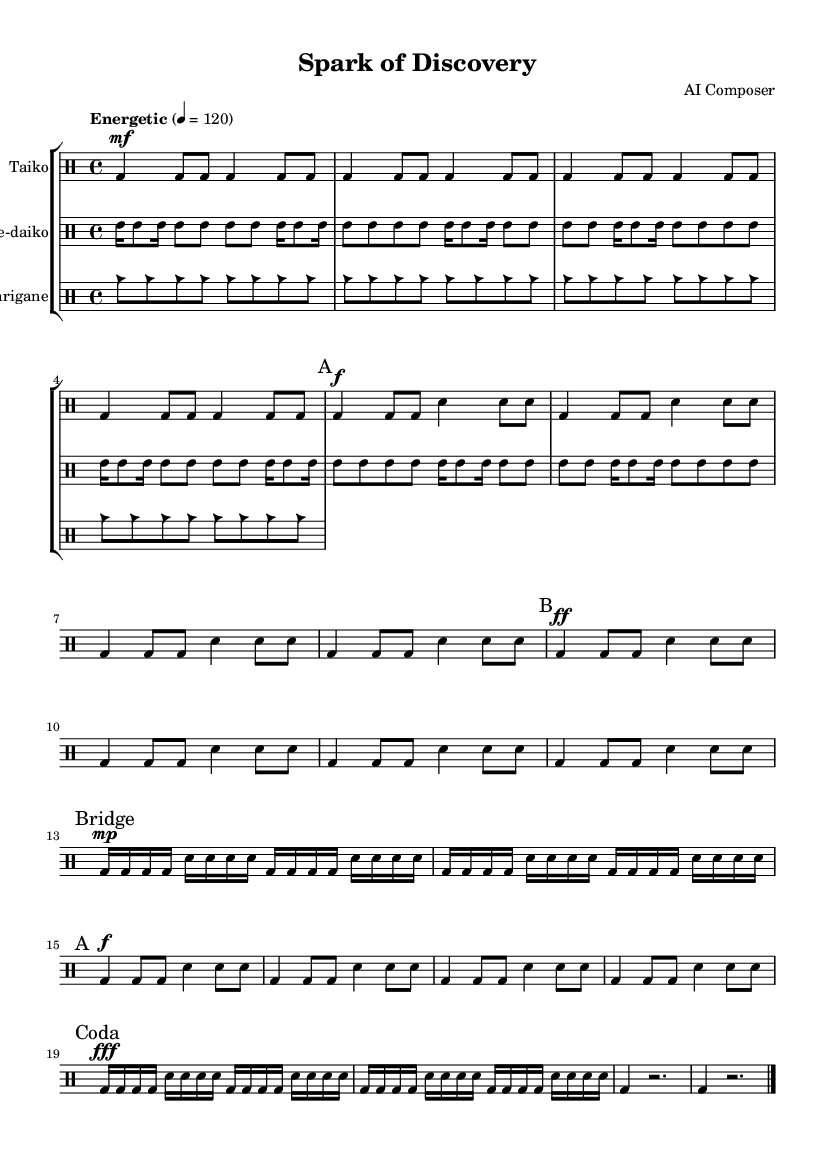What is the key signature of this music? The key signature indicated in the global section is C major, which has no sharps or flats. This is typically seen at the beginning of the sheet music.
Answer: C major What is the time signature of this music? The time signature specified in the global section is 4/4, meaning there are four beats per measure and a quarter note receives one beat. This can be confirmed by looking at the global settings at the start of the code.
Answer: 4/4 What is the tempo marking for this piece? The tempo marking provided in the global section is "Energetic" with a metronome marking of 120 beats per minute. This indicates the speed at which the piece should be played.
Answer: 120 How many main themes are in the music? Upon examining the structure of the piece, we can identify two main themes (A and B) that are explicitly marked in the music. Each theme has specific rhythmic patterns associated with it.
Answer: 2 What instruments are featured in this music? The sheet music includes three different instruments: Taiko, Shime-daiko, and Atarigane, as noted in the drum staff annotations provided in the score section.
Answer: Taiko, Shime-daiko, Atarigane What dynamic markings are used in theme A? In theme A, the dynamic markings indicate starting with a forte (f) and two measures with a mezzo-forte (mf). These dynamics are essential for conveying the energy of the Taiko drumming in the score.
Answer: mf, f What type of music is represented here? The music is characterized as Taiko drumming, a traditional Japanese percussion style known for its powerful and energetic rhythms, reflecting excitement in learning. The specific patterns and instrumentation align with this genre.
Answer: Taiko 